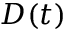Convert formula to latex. <formula><loc_0><loc_0><loc_500><loc_500>D ( t )</formula> 